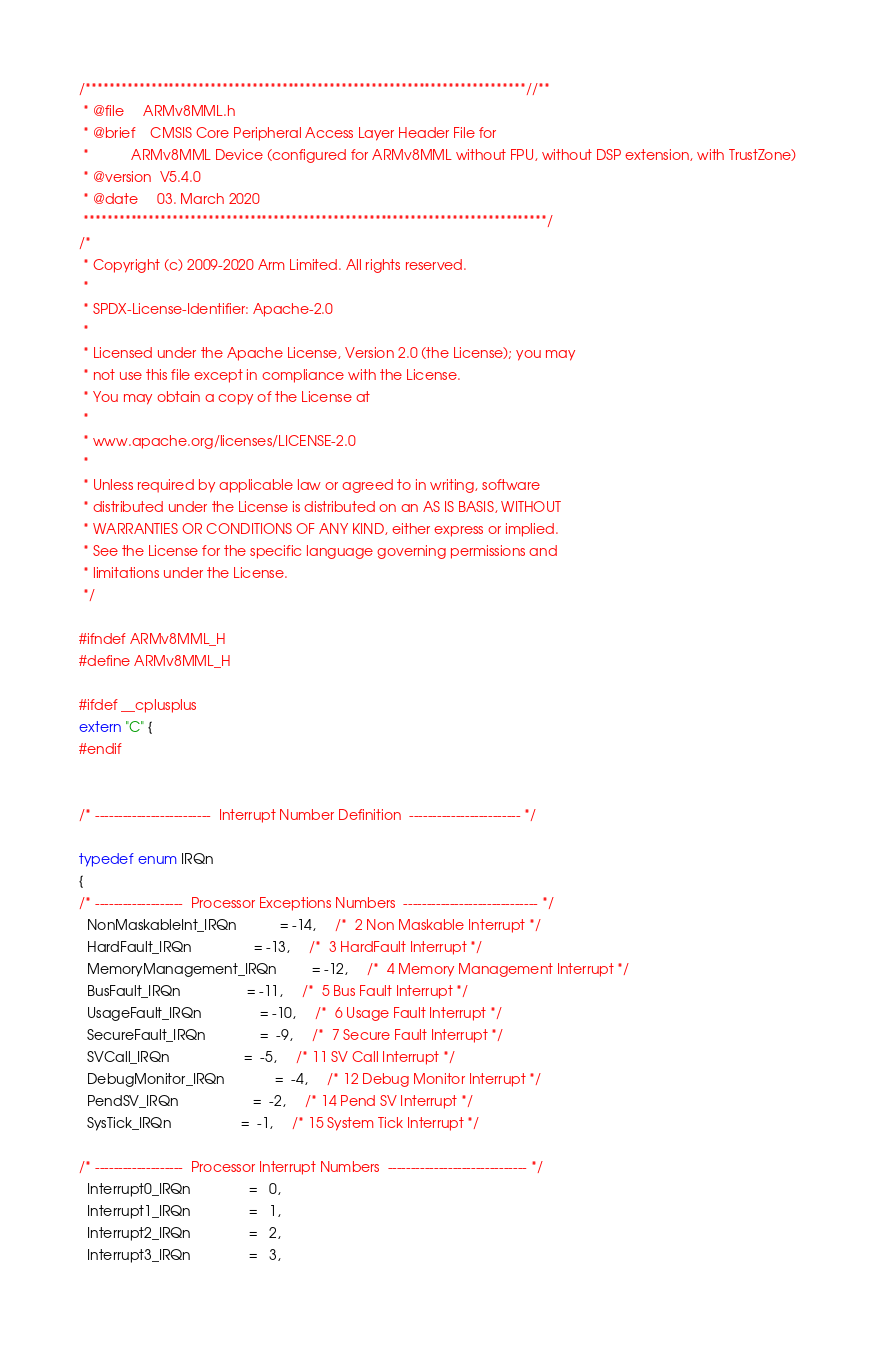Convert code to text. <code><loc_0><loc_0><loc_500><loc_500><_C_>/**************************************************************************//**
 * @file     ARMv8MML.h
 * @brief    CMSIS Core Peripheral Access Layer Header File for
 *           ARMv8MML Device (configured for ARMv8MML without FPU, without DSP extension, with TrustZone)
 * @version  V5.4.0
 * @date     03. March 2020
 ******************************************************************************/
/*
 * Copyright (c) 2009-2020 Arm Limited. All rights reserved.
 *
 * SPDX-License-Identifier: Apache-2.0
 *
 * Licensed under the Apache License, Version 2.0 (the License); you may
 * not use this file except in compliance with the License.
 * You may obtain a copy of the License at
 *
 * www.apache.org/licenses/LICENSE-2.0
 *
 * Unless required by applicable law or agreed to in writing, software
 * distributed under the License is distributed on an AS IS BASIS, WITHOUT
 * WARRANTIES OR CONDITIONS OF ANY KIND, either express or implied.
 * See the License for the specific language governing permissions and
 * limitations under the License.
 */

#ifndef ARMv8MML_H
#define ARMv8MML_H

#ifdef __cplusplus
extern "C" {
#endif


/* -------------------------  Interrupt Number Definition  ------------------------ */

typedef enum IRQn
{
/* -------------------  Processor Exceptions Numbers  ----------------------------- */
  NonMaskableInt_IRQn           = -14,     /*  2 Non Maskable Interrupt */
  HardFault_IRQn                = -13,     /*  3 HardFault Interrupt */
  MemoryManagement_IRQn         = -12,     /*  4 Memory Management Interrupt */
  BusFault_IRQn                 = -11,     /*  5 Bus Fault Interrupt */
  UsageFault_IRQn               = -10,     /*  6 Usage Fault Interrupt */
  SecureFault_IRQn              =  -9,     /*  7 Secure Fault Interrupt */
  SVCall_IRQn                   =  -5,     /* 11 SV Call Interrupt */
  DebugMonitor_IRQn             =  -4,     /* 12 Debug Monitor Interrupt */
  PendSV_IRQn                   =  -2,     /* 14 Pend SV Interrupt */
  SysTick_IRQn                  =  -1,     /* 15 System Tick Interrupt */

/* -------------------  Processor Interrupt Numbers  ------------------------------ */
  Interrupt0_IRQn               =   0,
  Interrupt1_IRQn               =   1,
  Interrupt2_IRQn               =   2,
  Interrupt3_IRQn               =   3,</code> 